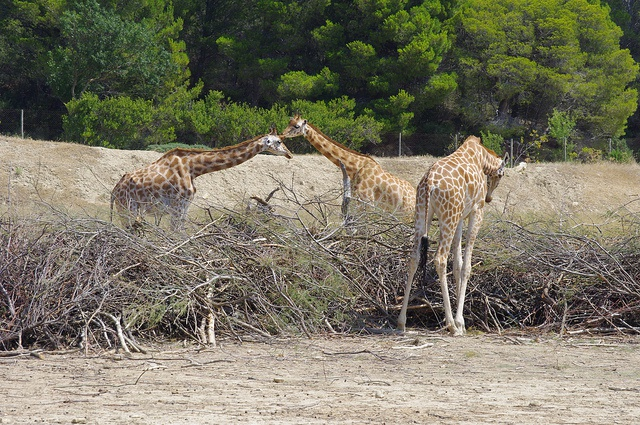Describe the objects in this image and their specific colors. I can see giraffe in black, darkgray, gray, tan, and lightgray tones, giraffe in black, gray, darkgray, and tan tones, and giraffe in black, tan, darkgray, and gray tones in this image. 